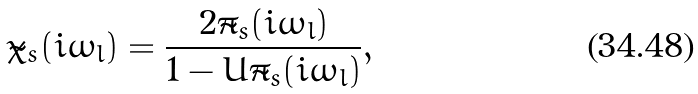Convert formula to latex. <formula><loc_0><loc_0><loc_500><loc_500>\tilde { \chi } _ { s } ( i \omega _ { l } ) = \frac { 2 \tilde { \pi } _ { s } ( i \omega _ { l } ) } { 1 - U \tilde { \pi } _ { s } ( i \omega _ { l } ) } ,</formula> 